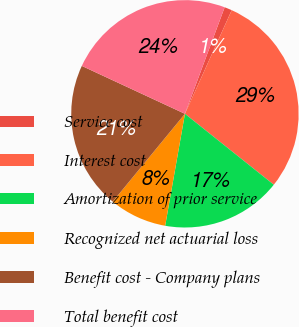Convert chart to OTSL. <chart><loc_0><loc_0><loc_500><loc_500><pie_chart><fcel>Service cost<fcel>Interest cost<fcel>Amortization of prior service<fcel>Recognized net actuarial loss<fcel>Benefit cost - Company plans<fcel>Total benefit cost<nl><fcel>1.07%<fcel>28.97%<fcel>17.06%<fcel>8.17%<fcel>20.97%<fcel>23.76%<nl></chart> 